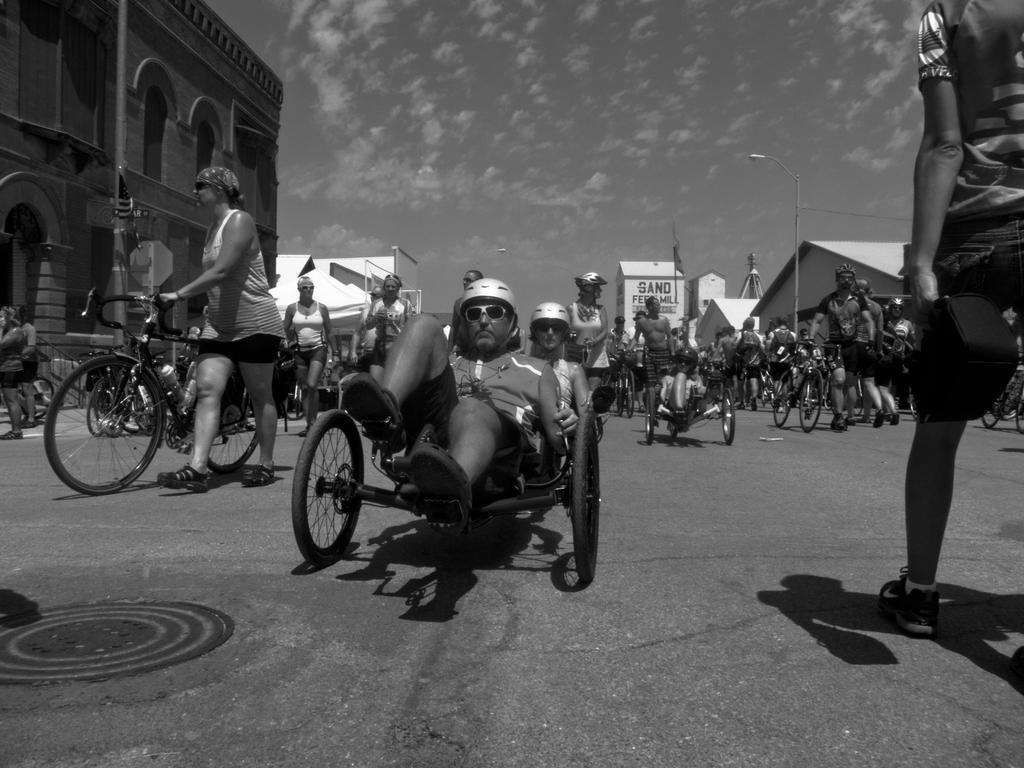What are the people in the image doing? There are people riding bicycles and some people are walking in the image. What can be seen in the background of the image? There are buildings, a pole, and the sky visible in the background of the image. What type of engine is attached to the bicycles in the image? There are no engines attached to the bicycles in the image; they are human-powered. What class is being taught in the background of the image? There is no class visible in the image; it only shows people riding bicycles, walking, and the background environment. 